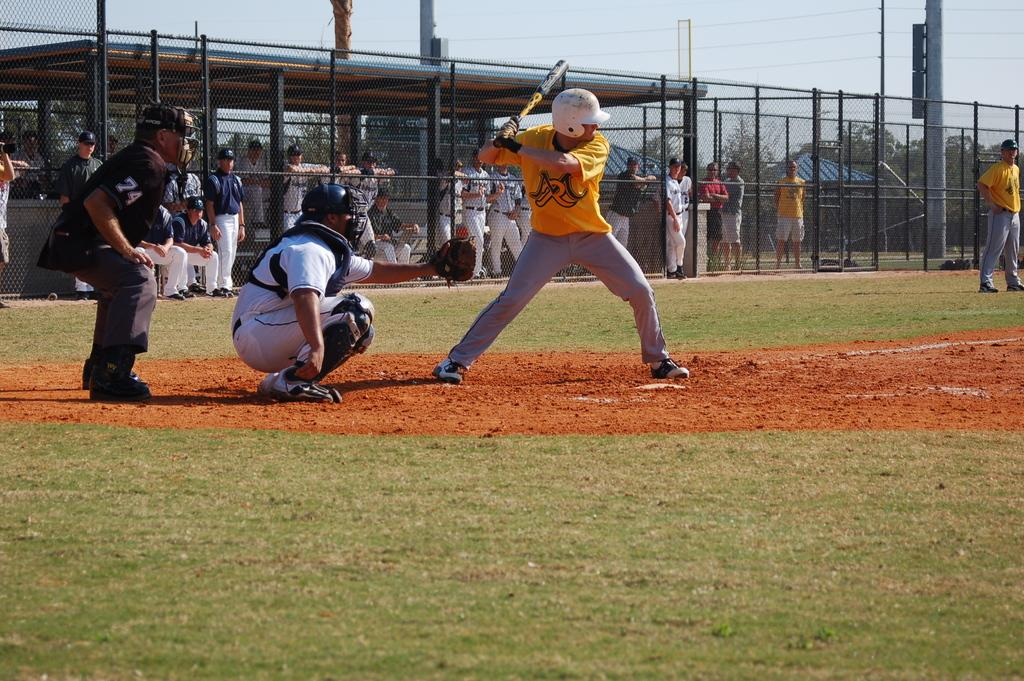Provide a one-sentence caption for the provided image. a baseball player that has the letter R on their jersey. 